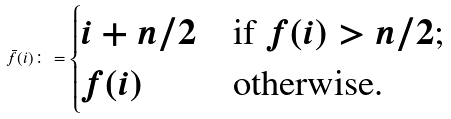<formula> <loc_0><loc_0><loc_500><loc_500>\bar { f } ( i ) \colon = \begin{cases} i + n / 2 & \text {if $f(i)>n/2$;} \\ f ( i ) & \text {otherwise.} \end{cases}</formula> 